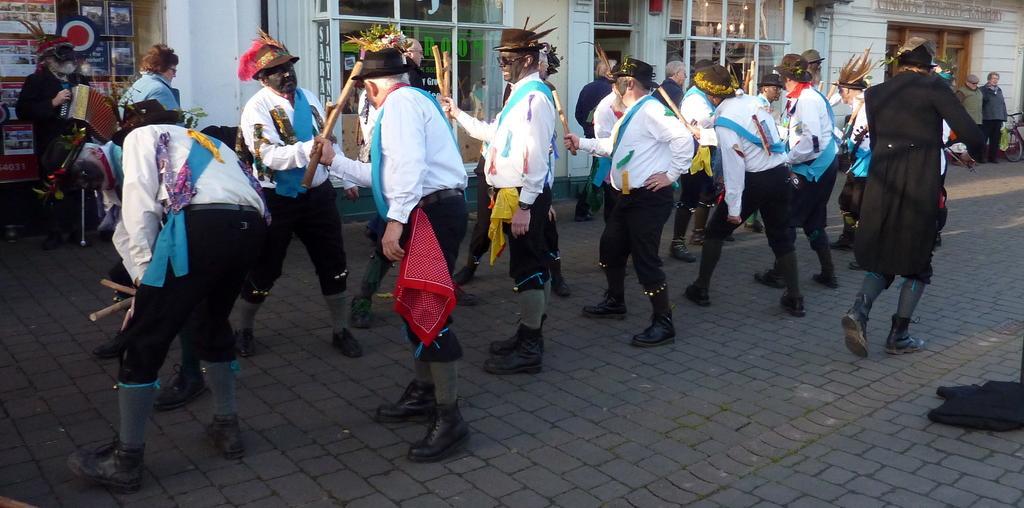Could you give a brief overview of what you see in this image? In this picture we can observe a group of men standing in front of each other wearing white and black color dresses. We can observe a blue color cloth across their shoulders. Everybody is wearing a hat on their head. In the background there is a building and there are some people in front of this building. 